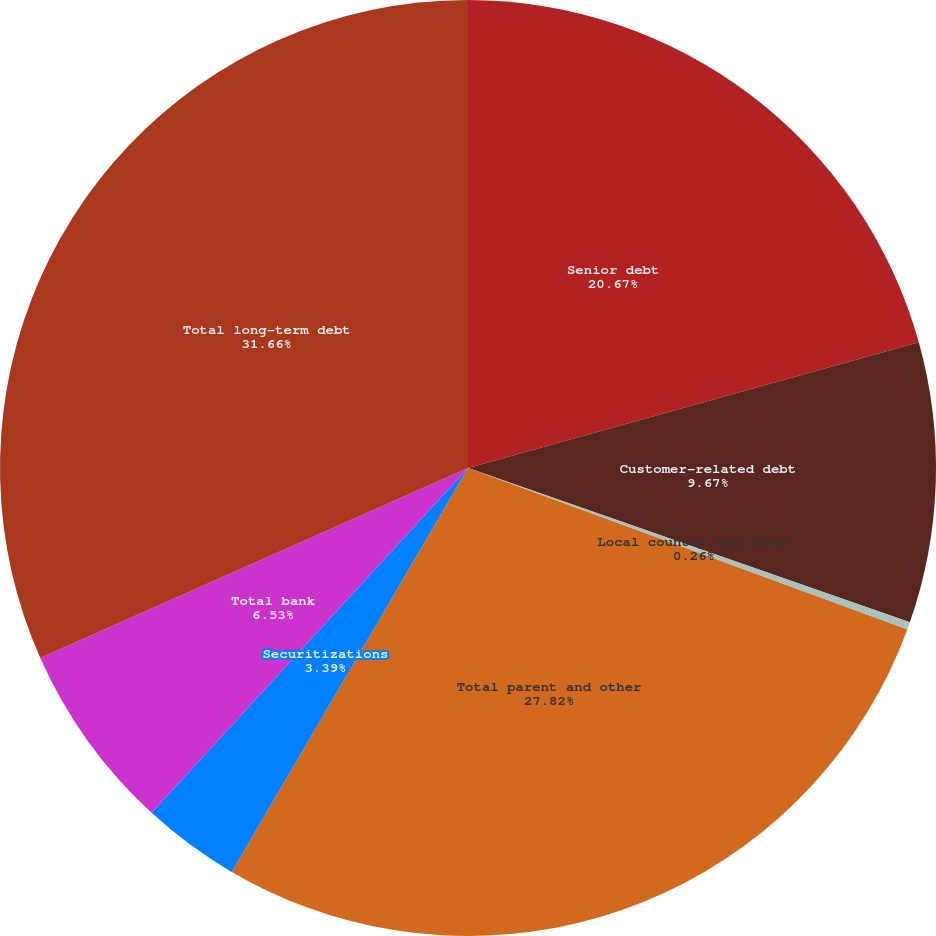<chart> <loc_0><loc_0><loc_500><loc_500><pie_chart><fcel>Senior debt<fcel>Customer-related debt<fcel>Local country and other<fcel>Total parent and other<fcel>Securitizations<fcel>Total bank<fcel>Total long-term debt<nl><fcel>20.67%<fcel>9.67%<fcel>0.26%<fcel>27.82%<fcel>3.39%<fcel>6.53%<fcel>31.65%<nl></chart> 